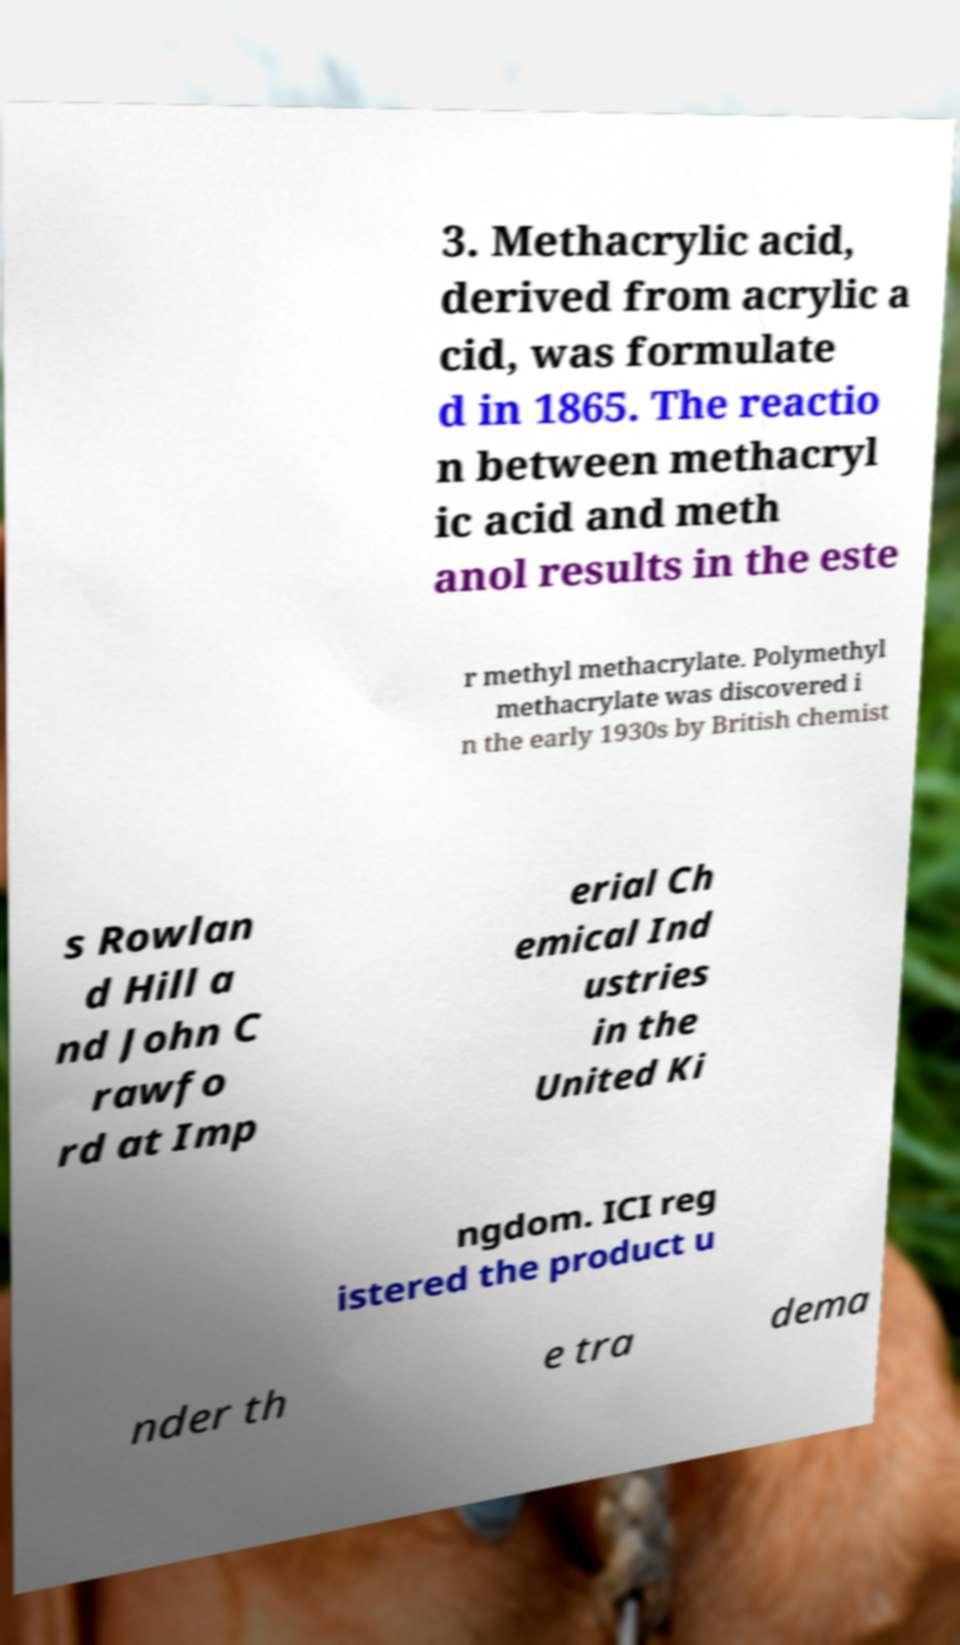Can you read and provide the text displayed in the image?This photo seems to have some interesting text. Can you extract and type it out for me? 3. Methacrylic acid, derived from acrylic a cid, was formulate d in 1865. The reactio n between methacryl ic acid and meth anol results in the este r methyl methacrylate. Polymethyl methacrylate was discovered i n the early 1930s by British chemist s Rowlan d Hill a nd John C rawfo rd at Imp erial Ch emical Ind ustries in the United Ki ngdom. ICI reg istered the product u nder th e tra dema 